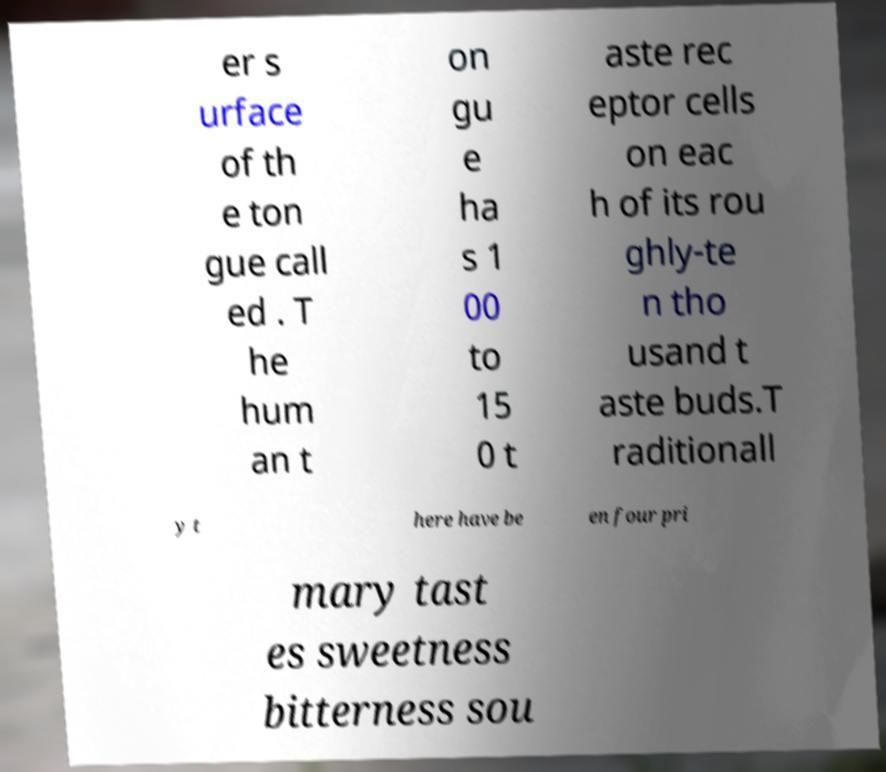Can you read and provide the text displayed in the image?This photo seems to have some interesting text. Can you extract and type it out for me? er s urface of th e ton gue call ed . T he hum an t on gu e ha s 1 00 to 15 0 t aste rec eptor cells on eac h of its rou ghly-te n tho usand t aste buds.T raditionall y t here have be en four pri mary tast es sweetness bitterness sou 